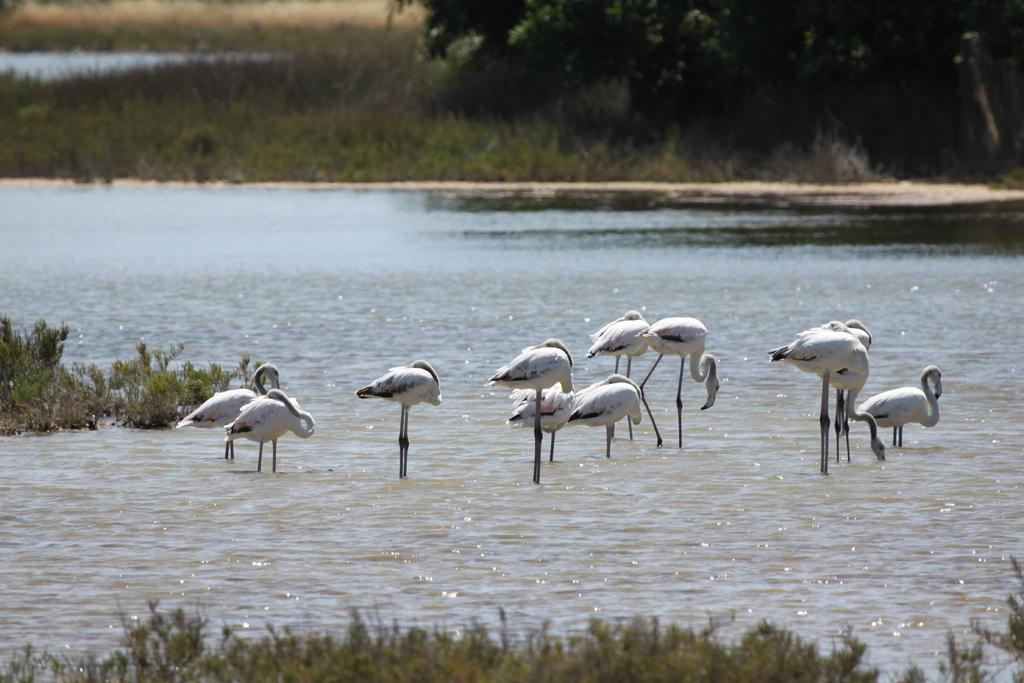What is located in the middle of the image? There is water and cranes in the middle of the image. What type of vegetation can be seen at the top of the image? There is grass and trees at the top of the image. How many parcels are being measured by the cranes in the image? There are no parcels present in the image, and the cranes are not measuring anything. What historical event is depicted in the image? There is no historical event depicted in the image; it features water, cranes, grass, and trees. 